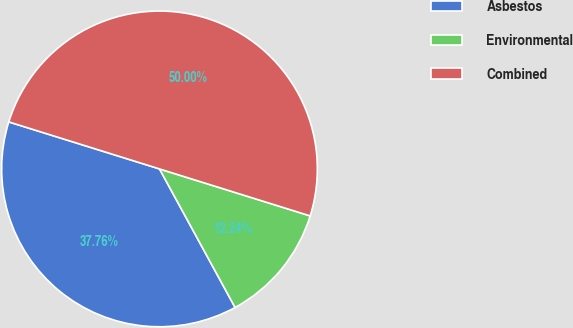Convert chart to OTSL. <chart><loc_0><loc_0><loc_500><loc_500><pie_chart><fcel>Asbestos<fcel>Environmental<fcel>Combined<nl><fcel>37.76%<fcel>12.24%<fcel>50.0%<nl></chart> 